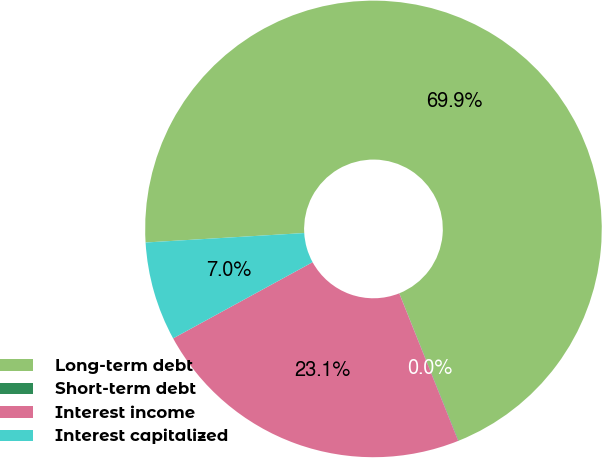<chart> <loc_0><loc_0><loc_500><loc_500><pie_chart><fcel>Long-term debt<fcel>Short-term debt<fcel>Interest income<fcel>Interest capitalized<nl><fcel>69.86%<fcel>0.03%<fcel>23.1%<fcel>7.01%<nl></chart> 